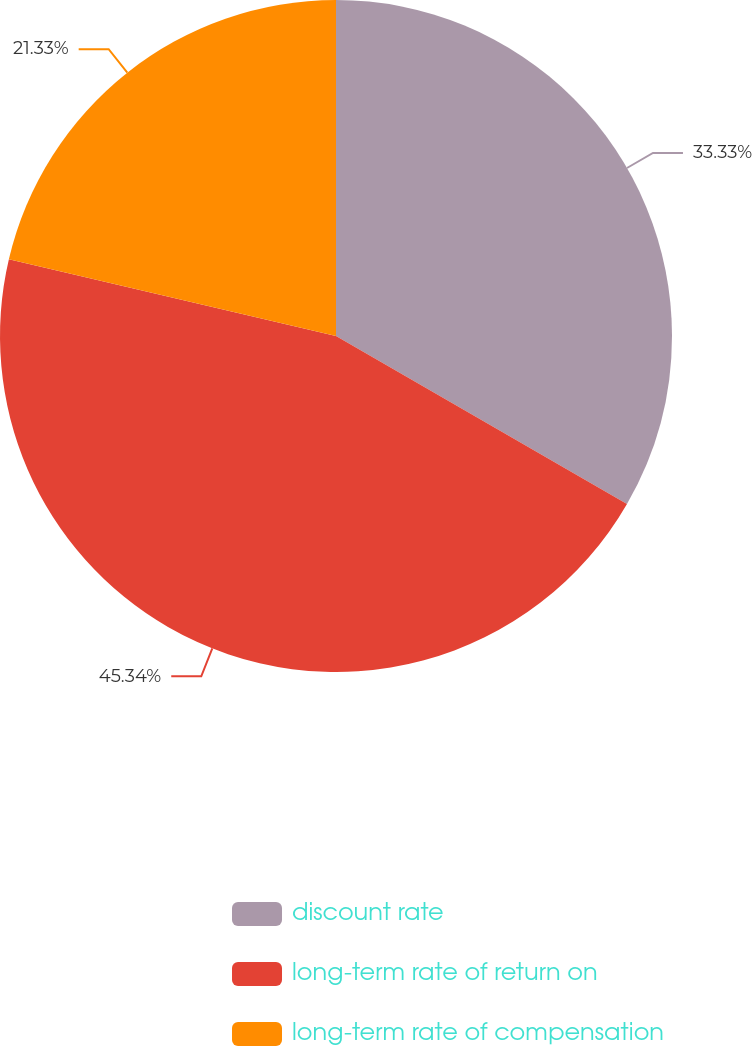Convert chart. <chart><loc_0><loc_0><loc_500><loc_500><pie_chart><fcel>discount rate<fcel>long-term rate of return on<fcel>long-term rate of compensation<nl><fcel>33.33%<fcel>45.33%<fcel>21.33%<nl></chart> 